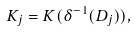Convert formula to latex. <formula><loc_0><loc_0><loc_500><loc_500>K _ { j } = K ( \delta ^ { - 1 } ( D _ { j } ) ) ,</formula> 